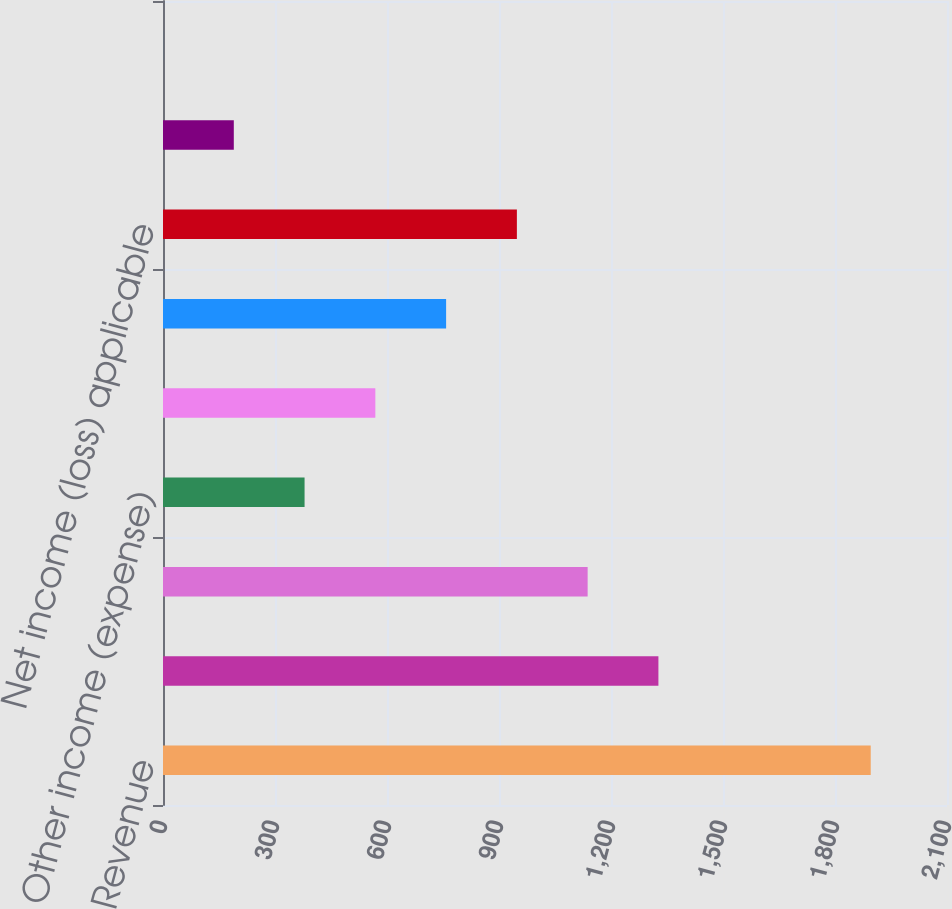<chart> <loc_0><loc_0><loc_500><loc_500><bar_chart><fcel>Revenue<fcel>Office and general expenses<fcel>Operating income (loss)<fcel>Other income (expense)<fcel>Total (expenses) and other<fcel>Net income (loss)<fcel>Net income (loss) applicable<fcel>Continuing operations<fcel>Total<nl><fcel>1895.7<fcel>1327<fcel>1137.44<fcel>379.2<fcel>568.76<fcel>758.32<fcel>947.88<fcel>189.64<fcel>0.08<nl></chart> 